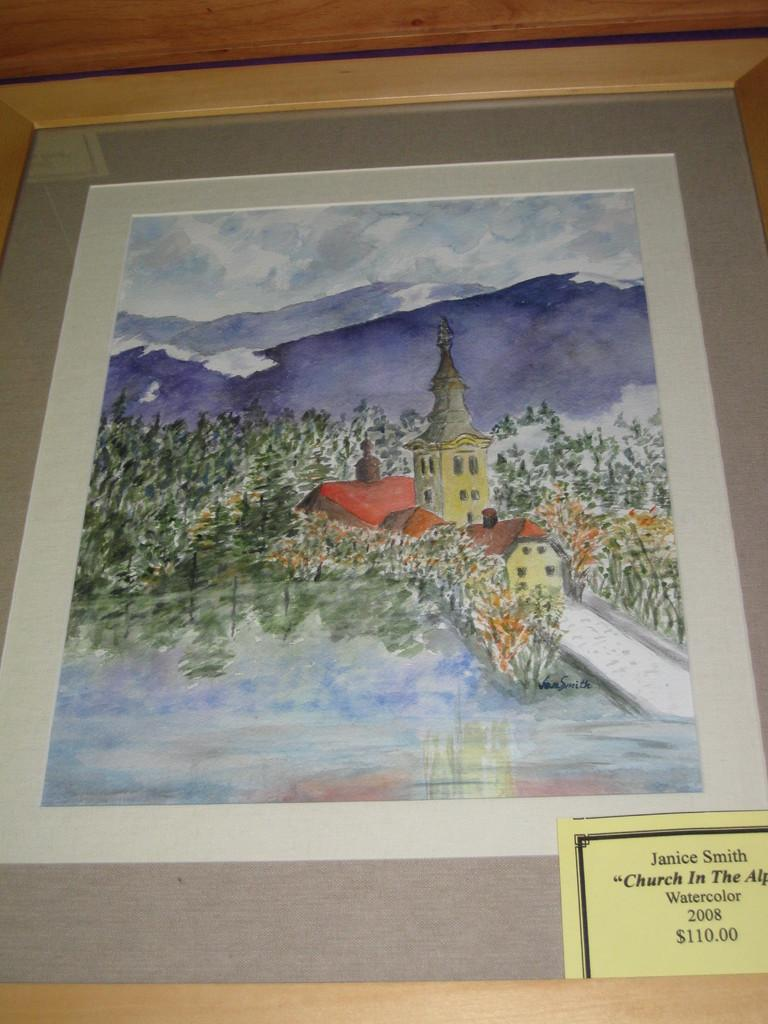<image>
Write a terse but informative summary of the picture. A watercolor painting from 2008 is by Janice Smith. 